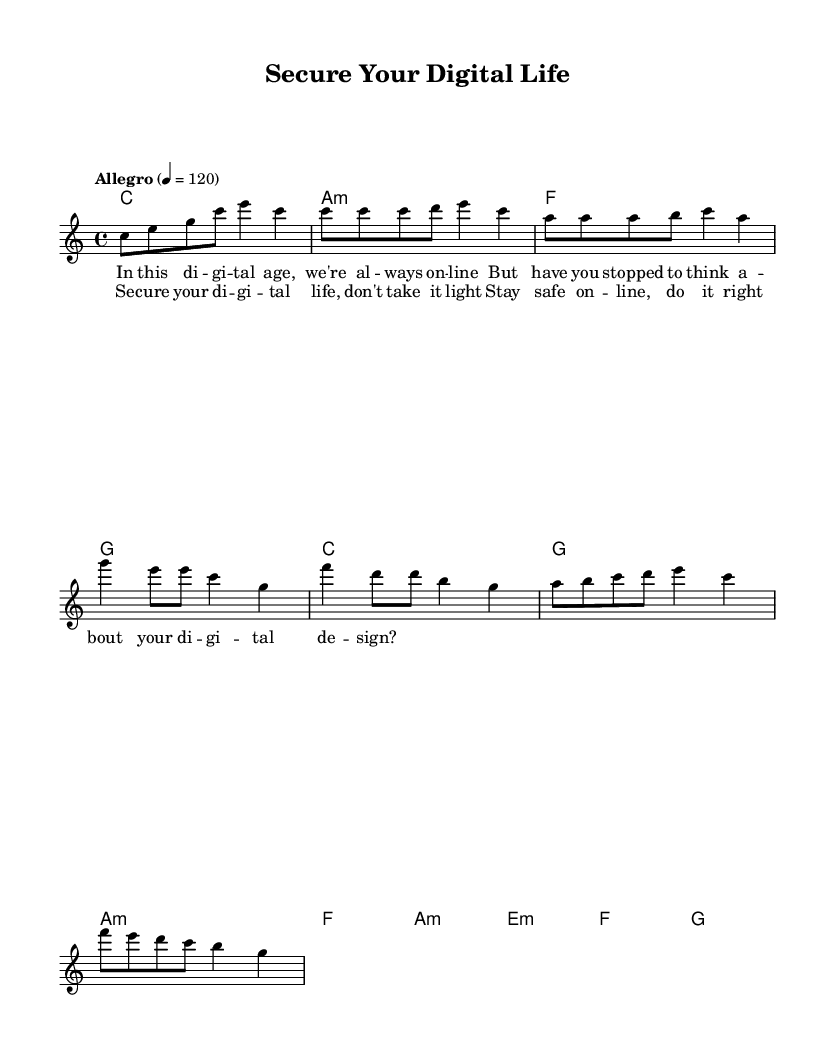What is the key signature of this music? The key signature is indicated at the beginning of the sheet music, and in this case, it is C major, which has no sharps or flats.
Answer: C major What is the time signature of the piece? The time signature can be found at the beginning of the score. Here, it is 4/4, which means there are four beats per measure and the quarter note gets one beat.
Answer: 4/4 What is the tempo marking for this piece? The tempo marking is noted within the score, stating "Allegro," which indicates a quick and lively pace. Additionally, it specifies the speed as 120 beats per minute.
Answer: Allegro How many measures are in the verse section? By analyzing the verse lyrics and the corresponding melody, we can count the measures in the verse. There are a total of four measures in the verse.
Answer: 4 What chords are used in the chorus? To determine the chords in the chorus, we refer to the chord symbols indicated above the chorus lyrics. The chorus comprises C, G, A minor, and F chords.
Answer: C, G, A minor, F What is the last note of the bridge? Looking at the bridge melody, the last note is a G, which is indicated in the melody line towards the end of the bridge section.
Answer: G What theme is discussed in the lyrics? The lyrics suggest a theme related to digital safety and online privacy, emphasizing the importance of securing one's digital life while being online.
Answer: Digital safety 